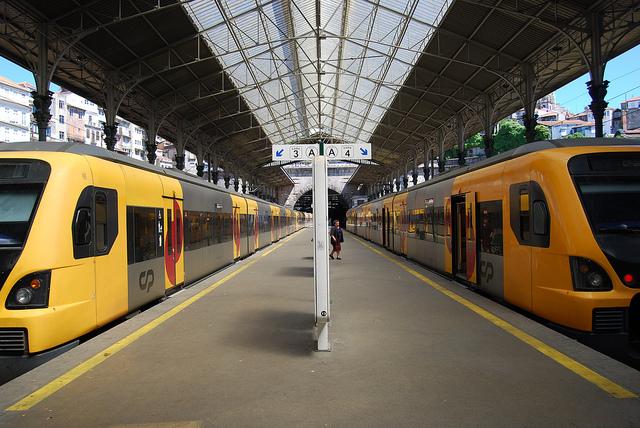Are these trains well-maintained?
Be succinct. Yes. What color are the trains?
Write a very short answer. Yellow. Does the weather look threatening?
Concise answer only. No. 